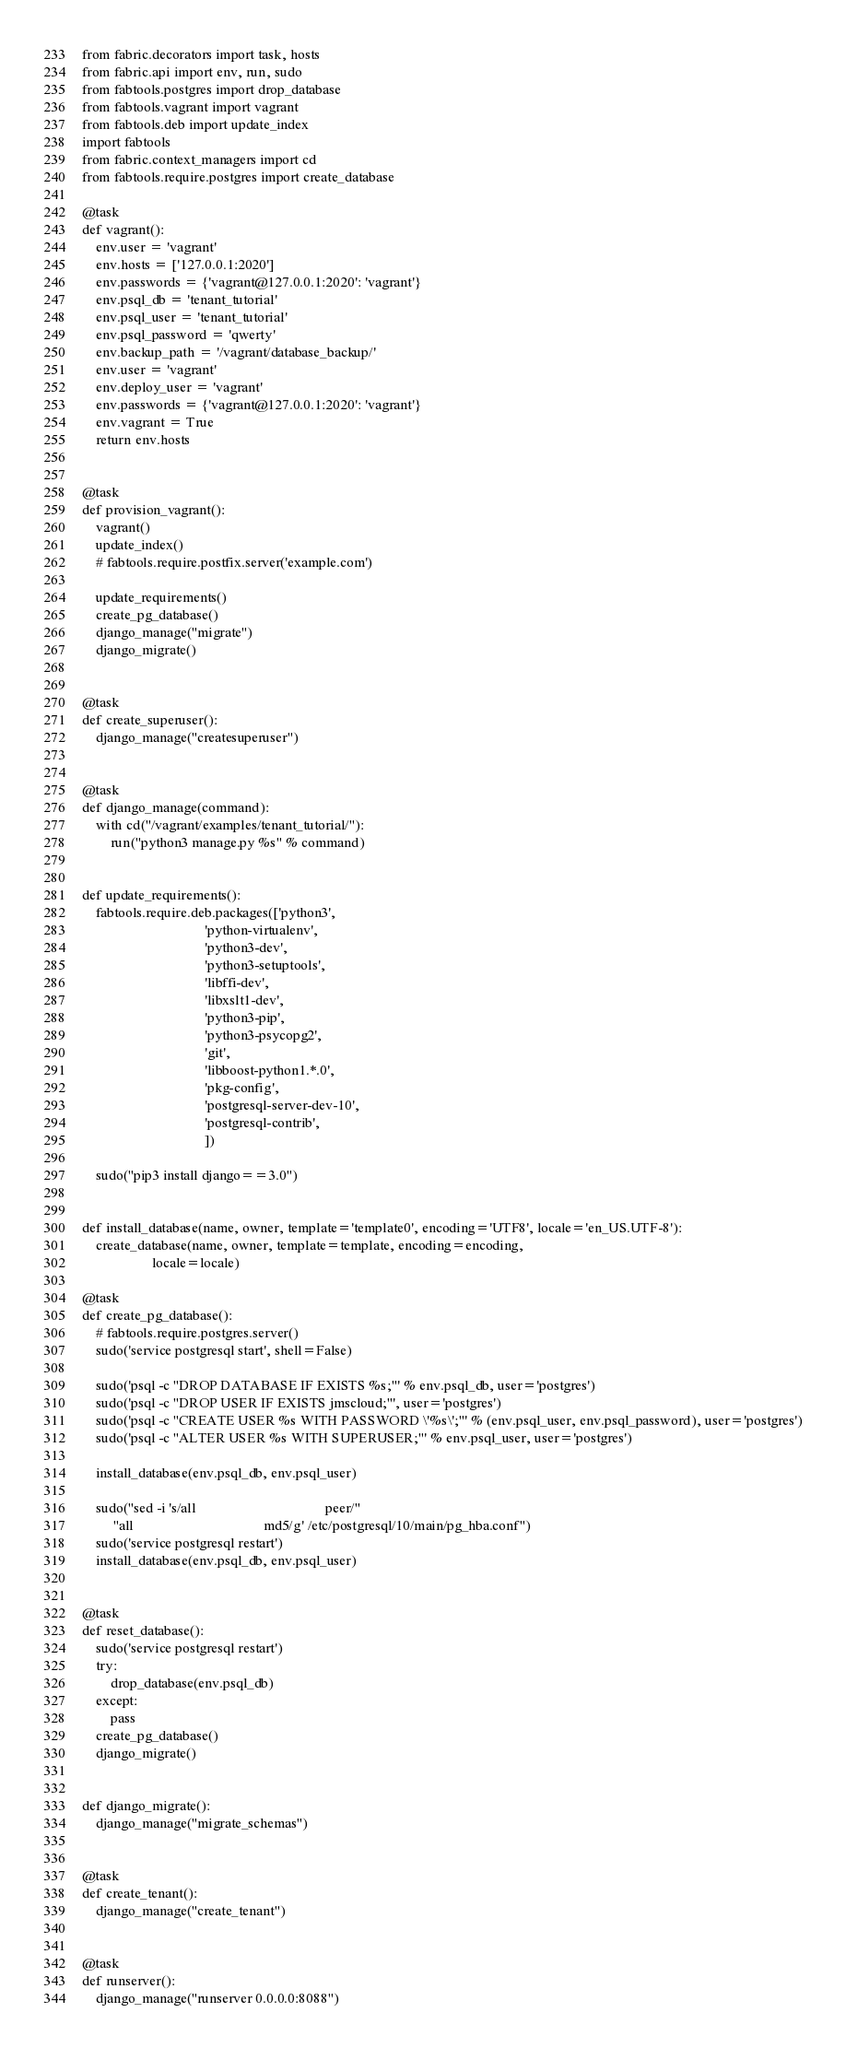Convert code to text. <code><loc_0><loc_0><loc_500><loc_500><_Python_>from fabric.decorators import task, hosts
from fabric.api import env, run, sudo
from fabtools.postgres import drop_database
from fabtools.vagrant import vagrant
from fabtools.deb import update_index
import fabtools
from fabric.context_managers import cd
from fabtools.require.postgres import create_database

@task
def vagrant():
    env.user = 'vagrant'
    env.hosts = ['127.0.0.1:2020']
    env.passwords = {'vagrant@127.0.0.1:2020': 'vagrant'}
    env.psql_db = 'tenant_tutorial'
    env.psql_user = 'tenant_tutorial'
    env.psql_password = 'qwerty'
    env.backup_path = '/vagrant/database_backup/'
    env.user = 'vagrant'
    env.deploy_user = 'vagrant'
    env.passwords = {'vagrant@127.0.0.1:2020': 'vagrant'}
    env.vagrant = True
    return env.hosts


@task
def provision_vagrant():
    vagrant()
    update_index()
    # fabtools.require.postfix.server('example.com')

    update_requirements()
    create_pg_database()
    django_manage("migrate")
    django_migrate()


@task
def create_superuser():
    django_manage("createsuperuser")


@task
def django_manage(command):
    with cd("/vagrant/examples/tenant_tutorial/"):
        run("python3 manage.py %s" % command)


def update_requirements():
    fabtools.require.deb.packages(['python3',
                                   'python-virtualenv',
                                   'python3-dev',
                                   'python3-setuptools',
                                   'libffi-dev',
                                   'libxslt1-dev',
                                   'python3-pip',
                                   'python3-psycopg2',
                                   'git',
                                   'libboost-python1.*.0',
                                   'pkg-config',
                                   'postgresql-server-dev-10',
                                   'postgresql-contrib',
                                   ])

    sudo("pip3 install django==3.0")


def install_database(name, owner, template='template0', encoding='UTF8', locale='en_US.UTF-8'):
    create_database(name, owner, template=template, encoding=encoding,
                    locale=locale)

@task
def create_pg_database():
    # fabtools.require.postgres.server()
    sudo('service postgresql start', shell=False)

    sudo('psql -c "DROP DATABASE IF EXISTS %s;"' % env.psql_db, user='postgres')
    sudo('psql -c "DROP USER IF EXISTS jmscloud;"', user='postgres')
    sudo('psql -c "CREATE USER %s WITH PASSWORD \'%s\';"' % (env.psql_user, env.psql_password), user='postgres')
    sudo('psql -c "ALTER USER %s WITH SUPERUSER;"' % env.psql_user, user='postgres')

    install_database(env.psql_db, env.psql_user)

    sudo("sed -i 's/all                                     peer/"
         "all                                     md5/g' /etc/postgresql/10/main/pg_hba.conf")
    sudo('service postgresql restart')
    install_database(env.psql_db, env.psql_user)


@task
def reset_database():
    sudo('service postgresql restart')
    try:
        drop_database(env.psql_db)
    except:
        pass
    create_pg_database()
    django_migrate()


def django_migrate():
    django_manage("migrate_schemas")


@task
def create_tenant():
    django_manage("create_tenant")


@task
def runserver():
    django_manage("runserver 0.0.0.0:8088")
</code> 